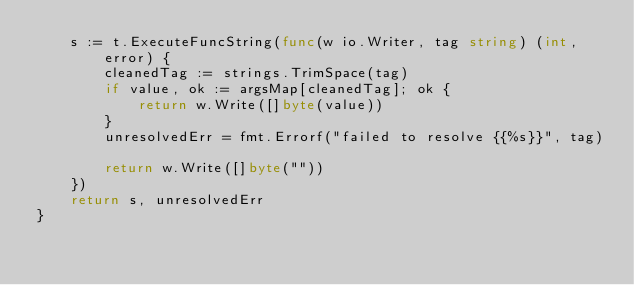<code> <loc_0><loc_0><loc_500><loc_500><_Go_>	s := t.ExecuteFuncString(func(w io.Writer, tag string) (int, error) {
		cleanedTag := strings.TrimSpace(tag)
		if value, ok := argsMap[cleanedTag]; ok {
			return w.Write([]byte(value))
		}
		unresolvedErr = fmt.Errorf("failed to resolve {{%s}}", tag)

		return w.Write([]byte(""))
	})
	return s, unresolvedErr
}
</code> 